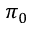<formula> <loc_0><loc_0><loc_500><loc_500>\pi _ { 0 }</formula> 